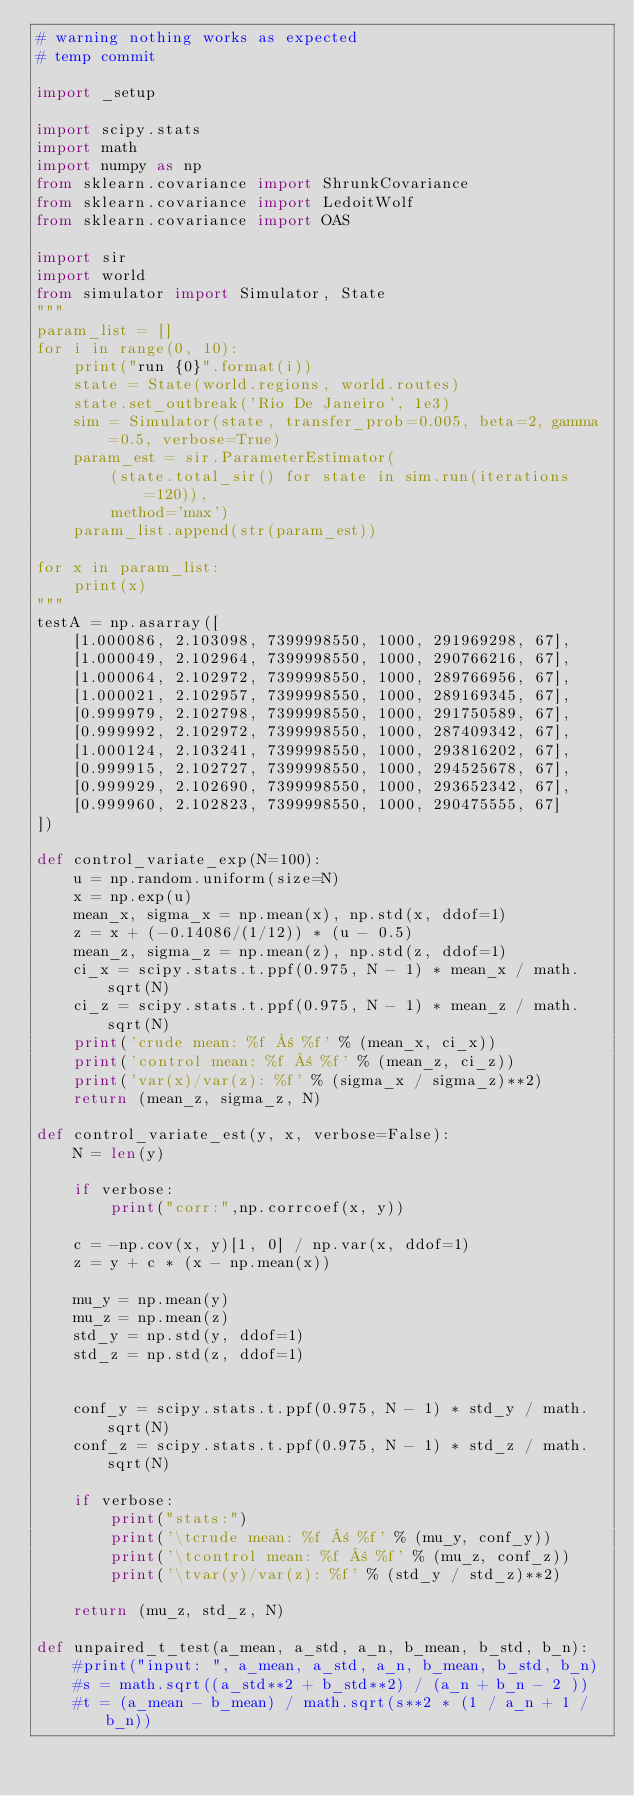Convert code to text. <code><loc_0><loc_0><loc_500><loc_500><_Python_># warning nothing works as expected
# temp commit

import _setup

import scipy.stats
import math
import numpy as np
from sklearn.covariance import ShrunkCovariance
from sklearn.covariance import LedoitWolf
from sklearn.covariance import OAS

import sir
import world
from simulator import Simulator, State
"""
param_list = []
for i in range(0, 10):
    print("run {0}".format(i))
    state = State(world.regions, world.routes)
    state.set_outbreak('Rio De Janeiro', 1e3)
    sim = Simulator(state, transfer_prob=0.005, beta=2, gamma=0.5, verbose=True)
    param_est = sir.ParameterEstimator(
        (state.total_sir() for state in sim.run(iterations=120)),
        method='max')
    param_list.append(str(param_est))

for x in param_list:
    print(x)
"""
testA = np.asarray([
    [1.000086, 2.103098, 7399998550, 1000, 291969298, 67],
    [1.000049, 2.102964, 7399998550, 1000, 290766216, 67],
    [1.000064, 2.102972, 7399998550, 1000, 289766956, 67],
    [1.000021, 2.102957, 7399998550, 1000, 289169345, 67],
    [0.999979, 2.102798, 7399998550, 1000, 291750589, 67],
    [0.999992, 2.102972, 7399998550, 1000, 287409342, 67],
    [1.000124, 2.103241, 7399998550, 1000, 293816202, 67],
    [0.999915, 2.102727, 7399998550, 1000, 294525678, 67],
    [0.999929, 2.102690, 7399998550, 1000, 293652342, 67],
    [0.999960, 2.102823, 7399998550, 1000, 290475555, 67]
])

def control_variate_exp(N=100):
    u = np.random.uniform(size=N)
    x = np.exp(u)
    mean_x, sigma_x = np.mean(x), np.std(x, ddof=1)
    z = x + (-0.14086/(1/12)) * (u - 0.5)
    mean_z, sigma_z = np.mean(z), np.std(z, ddof=1)
    ci_x = scipy.stats.t.ppf(0.975, N - 1) * mean_x / math.sqrt(N)
    ci_z = scipy.stats.t.ppf(0.975, N - 1) * mean_z / math.sqrt(N)
    print('crude mean: %f ± %f' % (mean_x, ci_x))
    print('control mean: %f ± %f' % (mean_z, ci_z))
    print('var(x)/var(z): %f' % (sigma_x / sigma_z)**2)
    return (mean_z, sigma_z, N)

def control_variate_est(y, x, verbose=False):
    N = len(y)

    if verbose:
        print("corr:",np.corrcoef(x, y))

    c = -np.cov(x, y)[1, 0] / np.var(x, ddof=1)
    z = y + c * (x - np.mean(x))

    mu_y = np.mean(y)
    mu_z = np.mean(z)
    std_y = np.std(y, ddof=1)
    std_z = np.std(z, ddof=1)


    conf_y = scipy.stats.t.ppf(0.975, N - 1) * std_y / math.sqrt(N)
    conf_z = scipy.stats.t.ppf(0.975, N - 1) * std_z / math.sqrt(N)

    if verbose:
        print("stats:")
        print('\tcrude mean: %f ± %f' % (mu_y, conf_y))
        print('\tcontrol mean: %f ± %f' % (mu_z, conf_z))
        print('\tvar(y)/var(z): %f' % (std_y / std_z)**2)

    return (mu_z, std_z, N)

def unpaired_t_test(a_mean, a_std, a_n, b_mean, b_std, b_n):
    #print("input: ", a_mean, a_std, a_n, b_mean, b_std, b_n)
    #s = math.sqrt((a_std**2 + b_std**2) / (a_n + b_n - 2 ))
    #t = (a_mean - b_mean) / math.sqrt(s**2 * (1 / a_n + 1 / b_n))</code> 